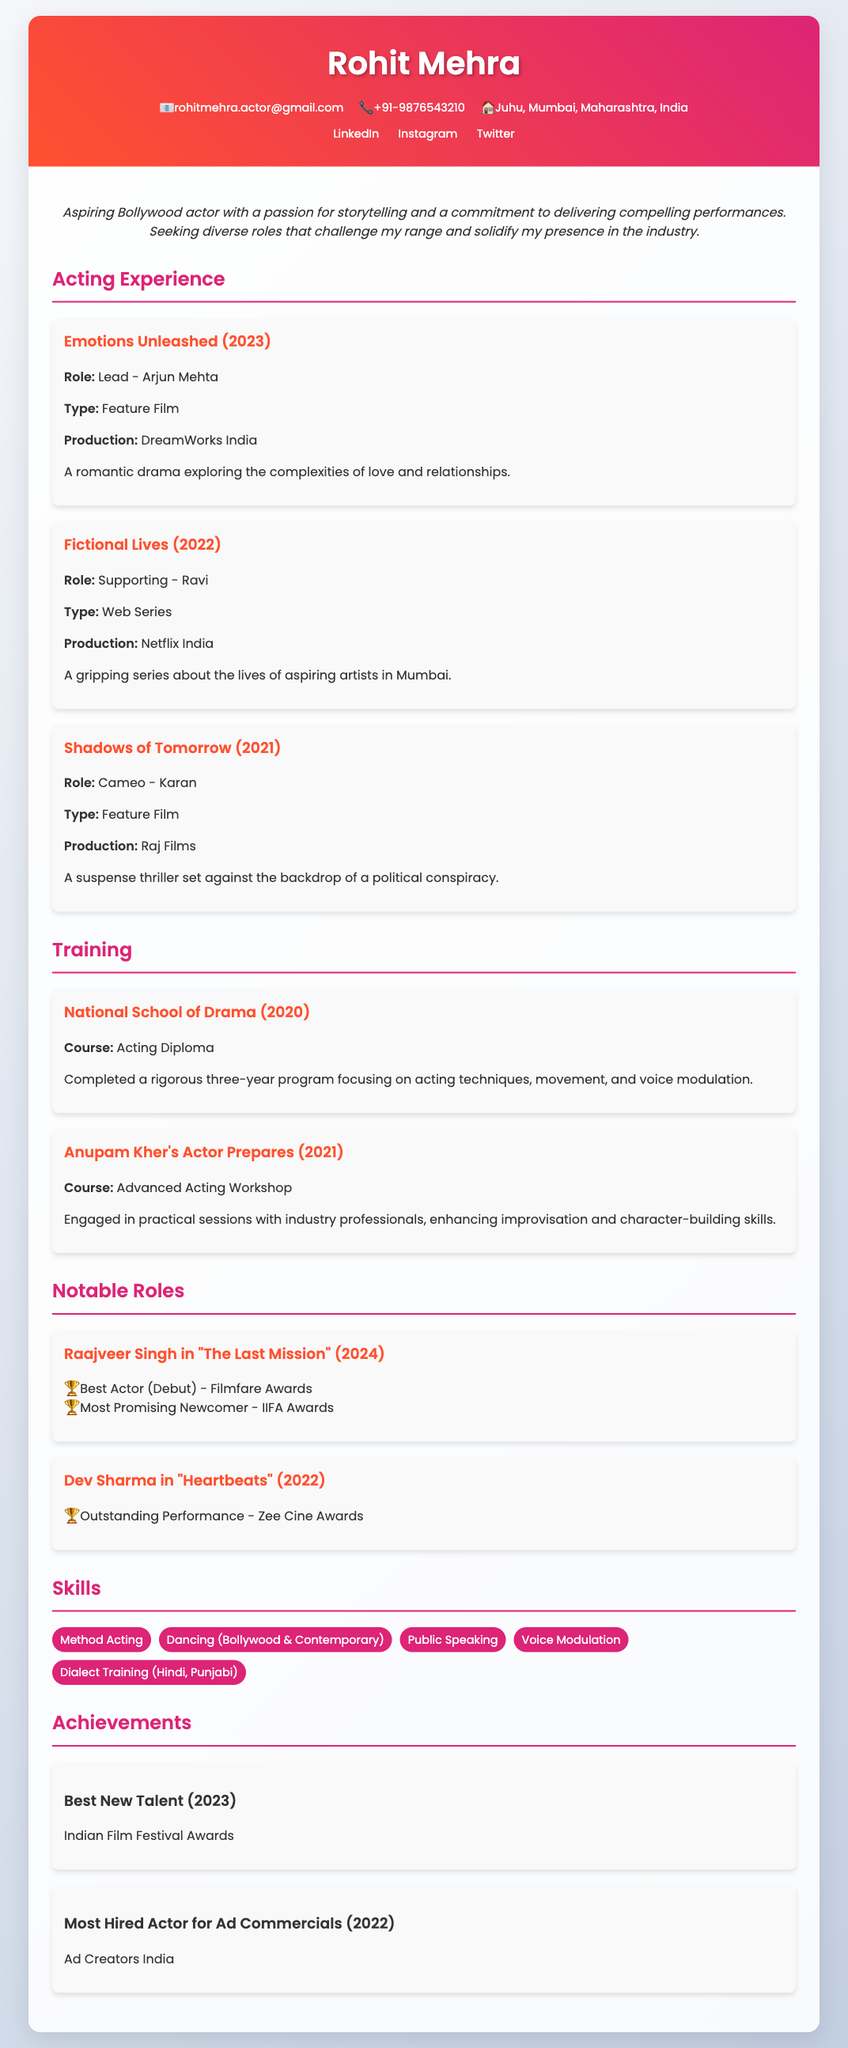what is Rohit Mehra's email address? The email address is listed in the contact info section.
Answer: rohitmehra.actor@gmail.com who produced the film "Emotions Unleashed"? The production company responsible for the film is mentioned in the experience section.
Answer: DreamWorks India which role did Rohit play in "Fictional Lives"? The specific role is detailed in the experience entry for the web series.
Answer: Supporting - Ravi when did Rohit attend the National School of Drama? The year of completion of the acting diploma is provided in the training section.
Answer: 2020 what award did Rohit win for his role as Raajveer Singh? The awards for notable roles are listed, specifically under the section for "The Last Mission."
Answer: Best Actor (Debut) how many skills are listed in the Skills section? The number of skills is determined by counting the items in the skills list.
Answer: 5 what was Rohit's first notable role? The notable roles are provided in chronological order, and the first one is mentioned in the list.
Answer: Raajveer Singh in "The Last Mission" who conducted the advanced acting workshop Rohit attended? The institution or individual that provided the workshop is stated in the training section.
Answer: Anupam Kher what is Rohit's acting objective? The objective statement is included at the beginning of the main content.
Answer: Aspiring Bollywood actor with a passion for storytelling 